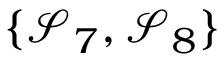Convert formula to latex. <formula><loc_0><loc_0><loc_500><loc_500>\{ \mathcal { S } _ { 7 } , \mathcal { S } _ { 8 } \}</formula> 